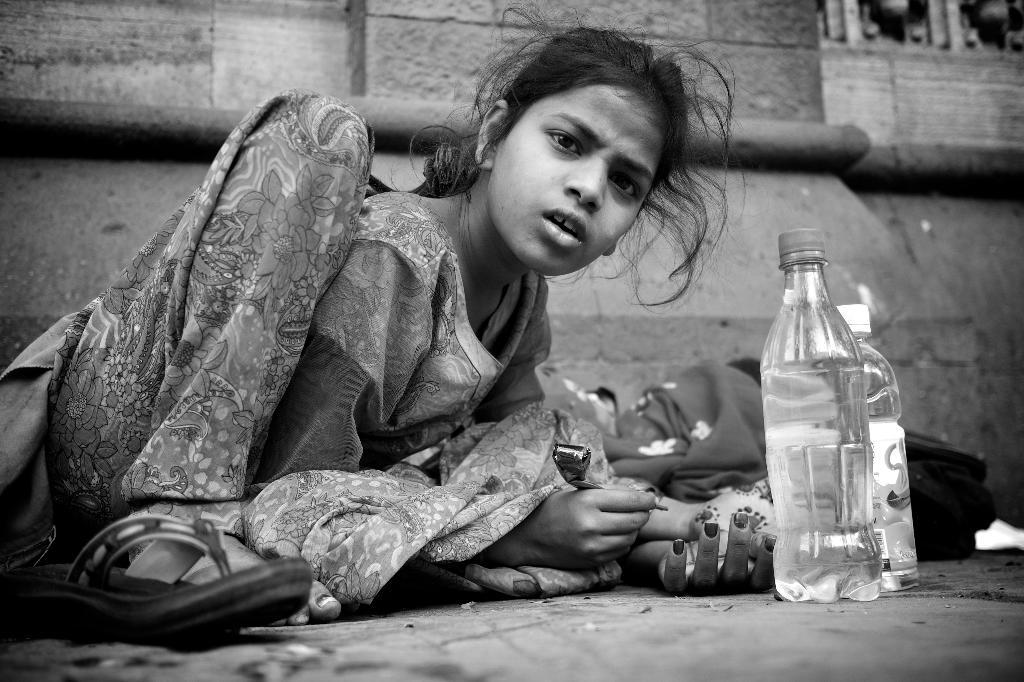What is the woman doing in the image? The woman is sitting on the floor. What is the woman holding in the image? The woman is holding a mehndi tube. What direction is the woman looking in the image? The woman is looking to the side. What objects are in front of the woman? There are bottles in front of her. What books does the woman have in her hands in the image? There are no books visible in the image; the woman is holding a mehndi tube. What example of shame can be seen in the woman's expression in the image? There is no indication of shame in the woman's expression or the image itself, as the focus is on her holding a mehndi tube and looking to the side. 